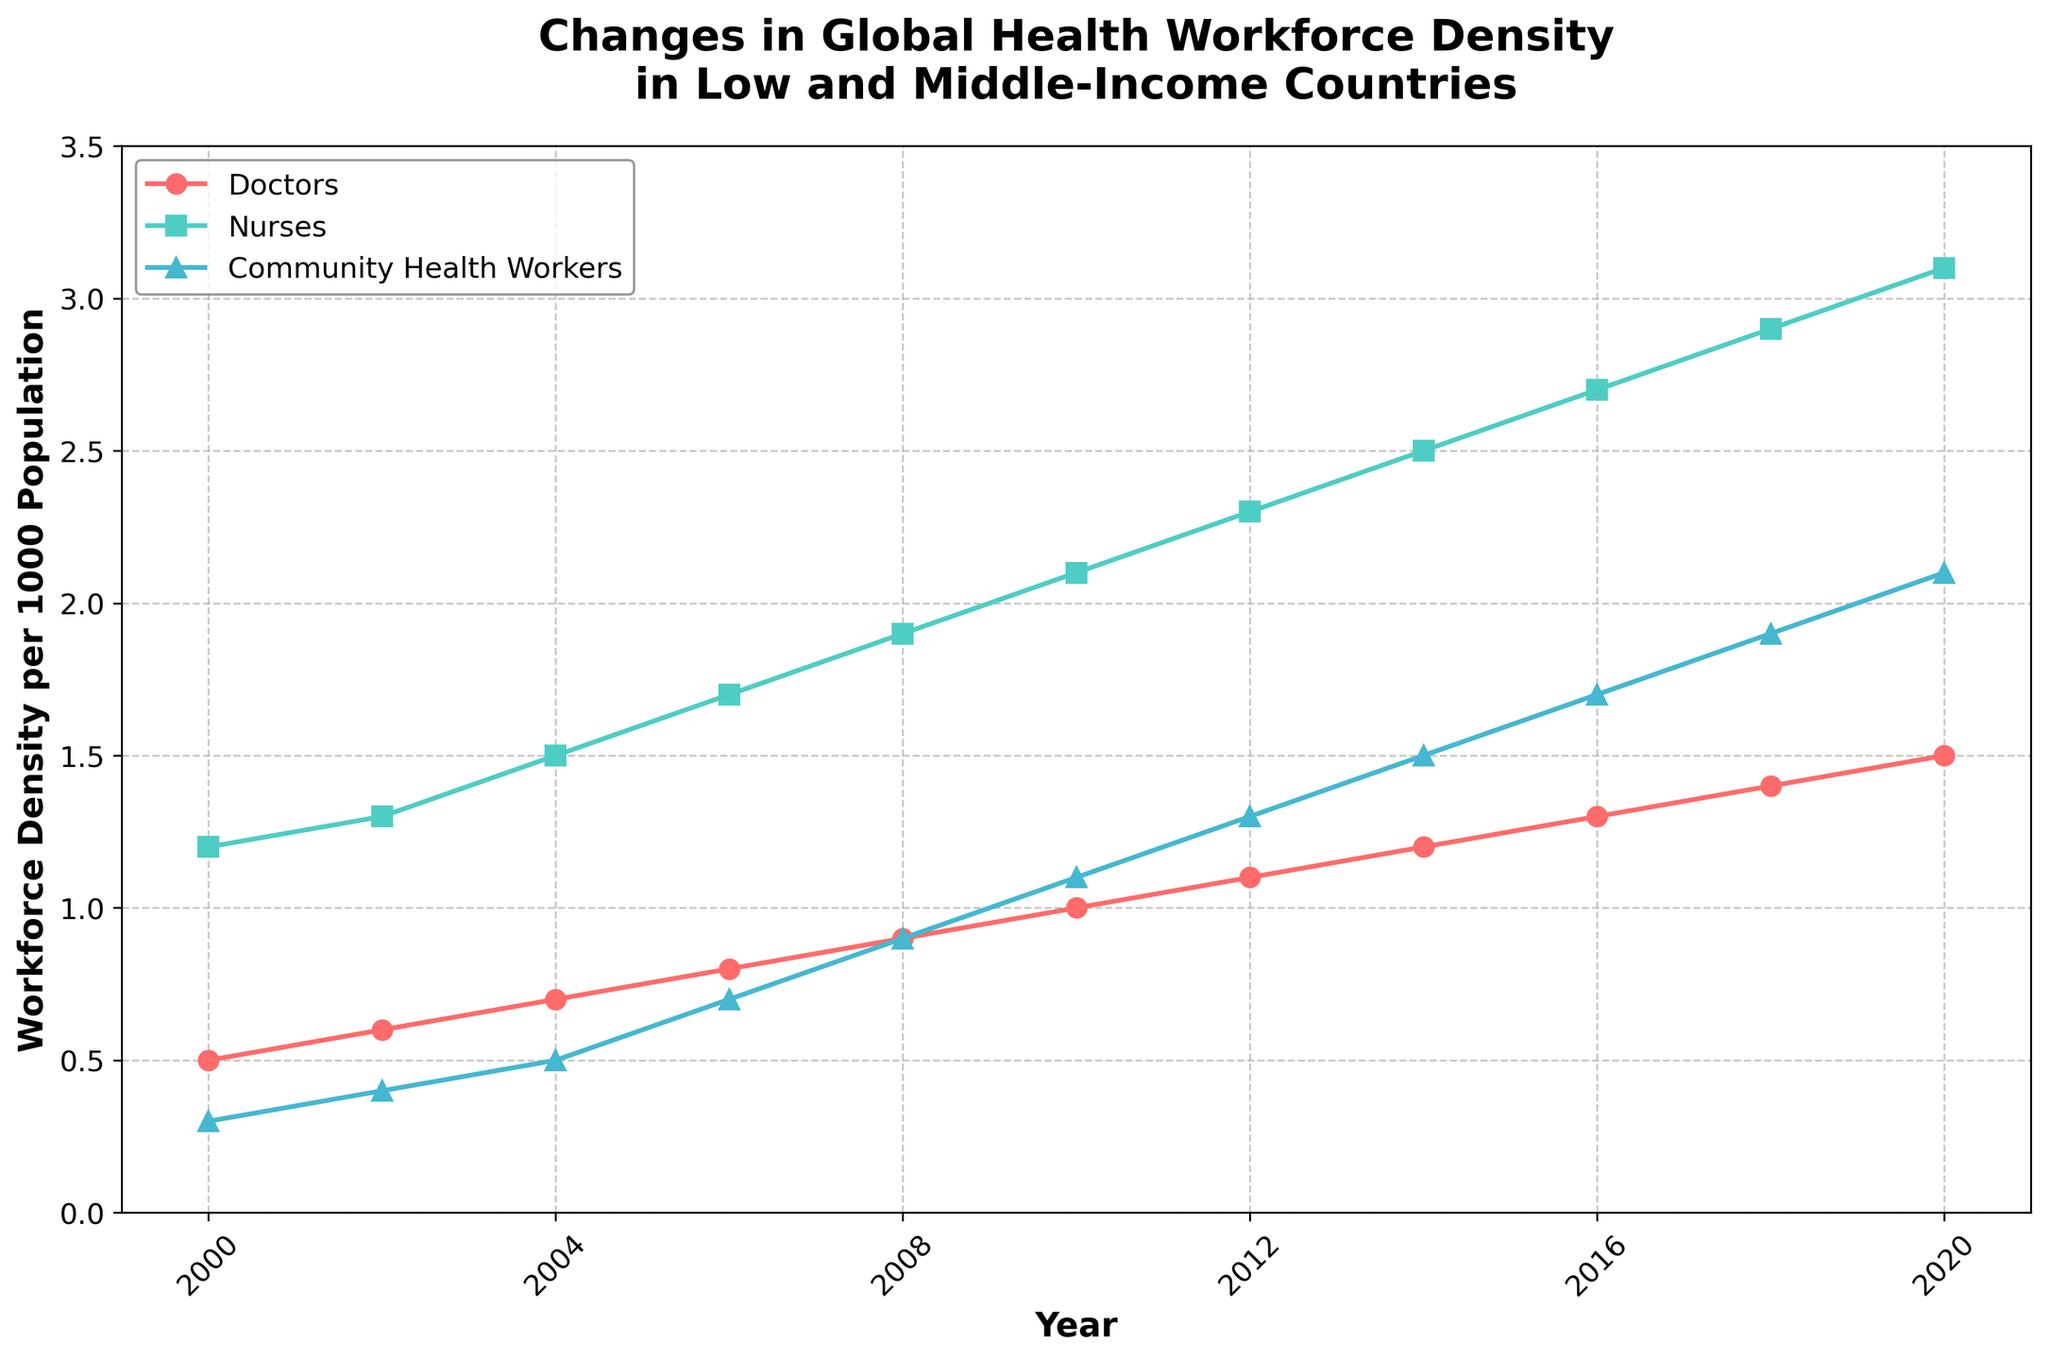Which category of health workers has shown the steepest increase in density per 1000 population from 2000 to 2020? To determine the category with the steepest increase, observe the slopes of the lines representing each category between 2000 and 2020. The line with the steepest slope indicates the highest rate of increase. The Community Health Workers (blue line) show the most significant change from 0.3 to 2.1, indicating the steepest increase.
Answer: Community Health Workers How much did the density of nurses per 1000 population increase from 2010 to 2020? To find the increase, subtract the value for 2010 from the value for 2020: Nurses in 2020 (3.1) - Nurses in 2010 (2.1) = 1.0
Answer: 1.0 Which year did doctors' density per 1000 population reach 1.0? To find this, observe the red line representing doctors and see where it crosses the 1.0 mark on the y-axis. It reaches 1.0 in the year 2010.
Answer: 2010 Compare the density growth of community health workers and nurses between 2008 and 2012. Which category grew more? To find this, calculate the changes for each category: Community Health Workers: 1.3 - 0.9 = 0.4, Nurses: 2.3 - 1.9 = 0.4. Both categories grew equally by 0.4 per 1000 population.
Answer: Equal growth In which year did the density of nurses per 1000 population first exceed 2.0? To determine this, examine the green line representing nurses and find the first year it goes above 2.0. The density first exceeds 2.0 in 2010.
Answer: 2010 What's the average annual increase in the density of doctors from 2000 to 2010? Calculate the total increase (1.0 - 0.5 = 0.5), then divide by the number of years (2010-2000 = 10 years): 0.5 / 10 = 0.05.
Answer: 0.05 Which category of health workers had the lowest density per 1000 population in 2016? To find this, compare the values for all categories in 2016: Doctors (1.3), Nurses (2.7), Community Health Workers (1.7). Doctors have the lowest density.
Answer: Doctors By how much did the density of community health workers increase per year on average from 2004 to 2008? Calculate the total increase (0.9 - 0.5 = 0.4), then divide by the number of years (2008-2004 = 4 years): 0.4 / 4 = 0.1.
Answer: 0.1 Which category showed a consistent increase in density every observed year without any decline? Observe each line and see if any category shows a consistent upward trend without any years where the value decreased. All three categories (Doctors, Nurses, Community Health Workers) show a consistent increase every year.
Answer: All three categories 